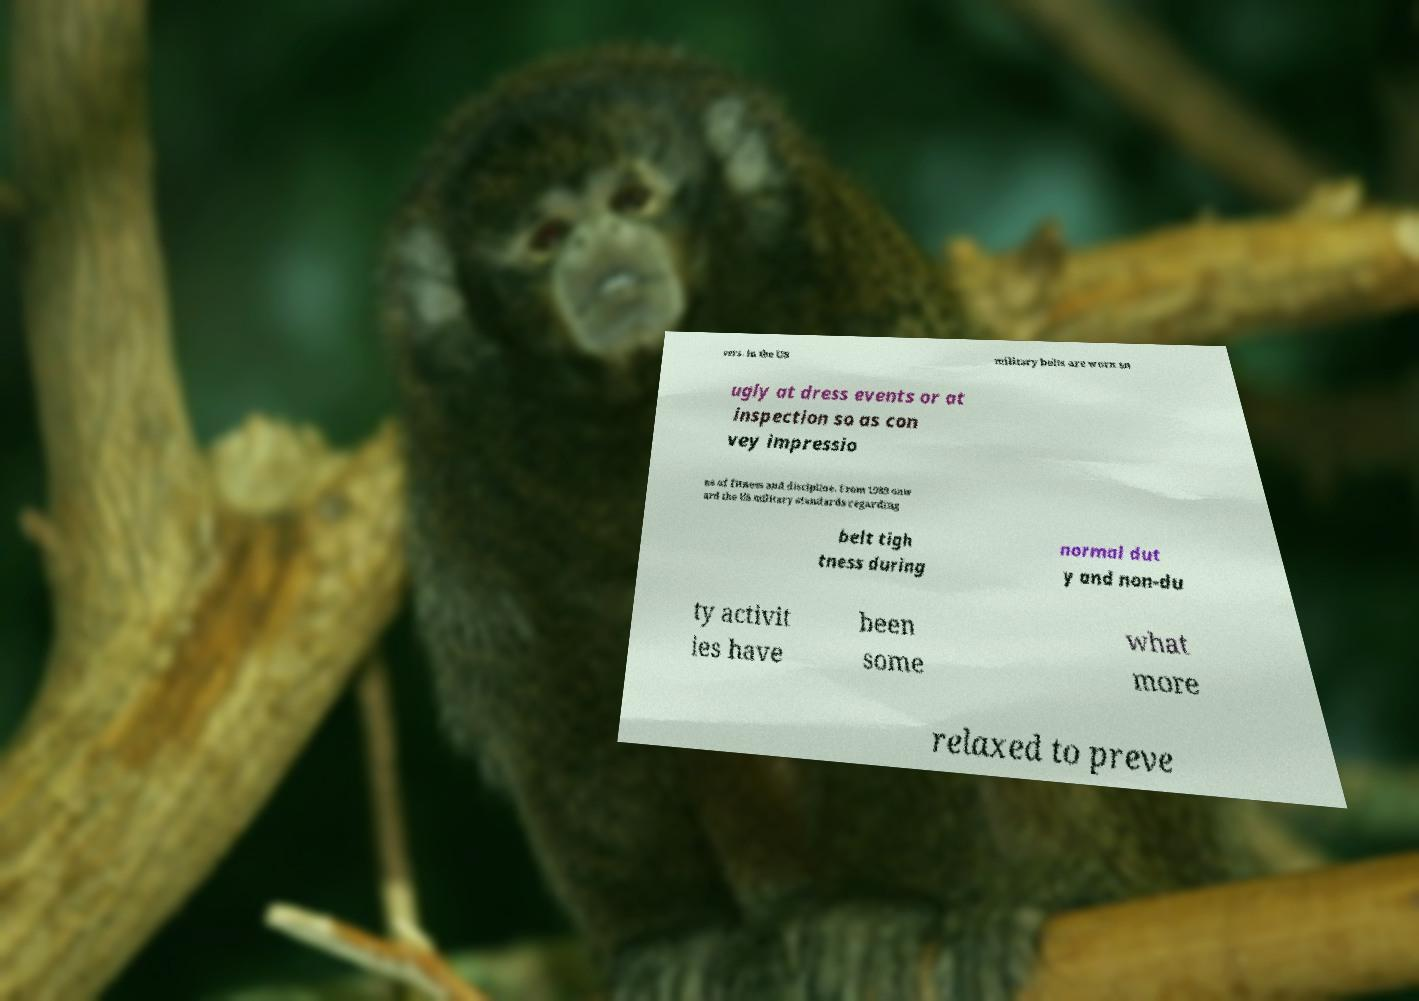Please identify and transcribe the text found in this image. sers. In the US military belts are worn sn ugly at dress events or at inspection so as con vey impressio ns of fitness and discipline. From 1989 onw ard the US military standards regarding belt tigh tness during normal dut y and non-du ty activit ies have been some what more relaxed to preve 